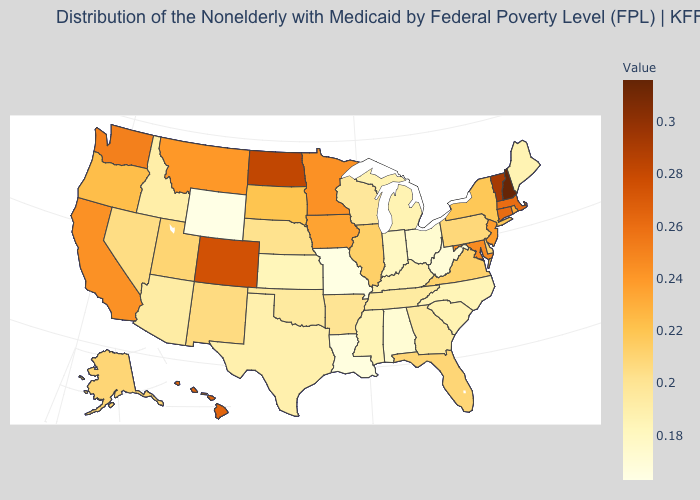Among the states that border New Jersey , which have the lowest value?
Write a very short answer. Pennsylvania. Which states have the lowest value in the USA?
Keep it brief. Wyoming. Among the states that border Connecticut , which have the lowest value?
Concise answer only. New York. 